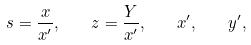Convert formula to latex. <formula><loc_0><loc_0><loc_500><loc_500>s = \frac { x } { x ^ { \prime } } , \quad z = \frac { Y } { x ^ { \prime } } , \quad x ^ { \prime } , \quad y ^ { \prime } ,</formula> 